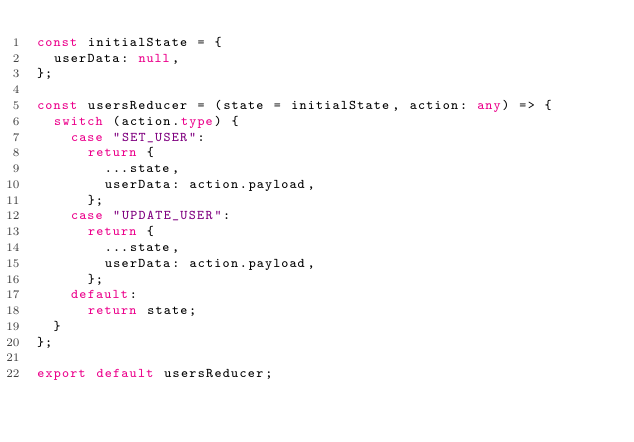<code> <loc_0><loc_0><loc_500><loc_500><_TypeScript_>const initialState = {
  userData: null,
};

const usersReducer = (state = initialState, action: any) => {
  switch (action.type) {
    case "SET_USER":
      return {
        ...state,
        userData: action.payload,
      };
    case "UPDATE_USER":
      return {
        ...state,
        userData: action.payload,
      };
    default:
      return state;
  }
};

export default usersReducer;
</code> 